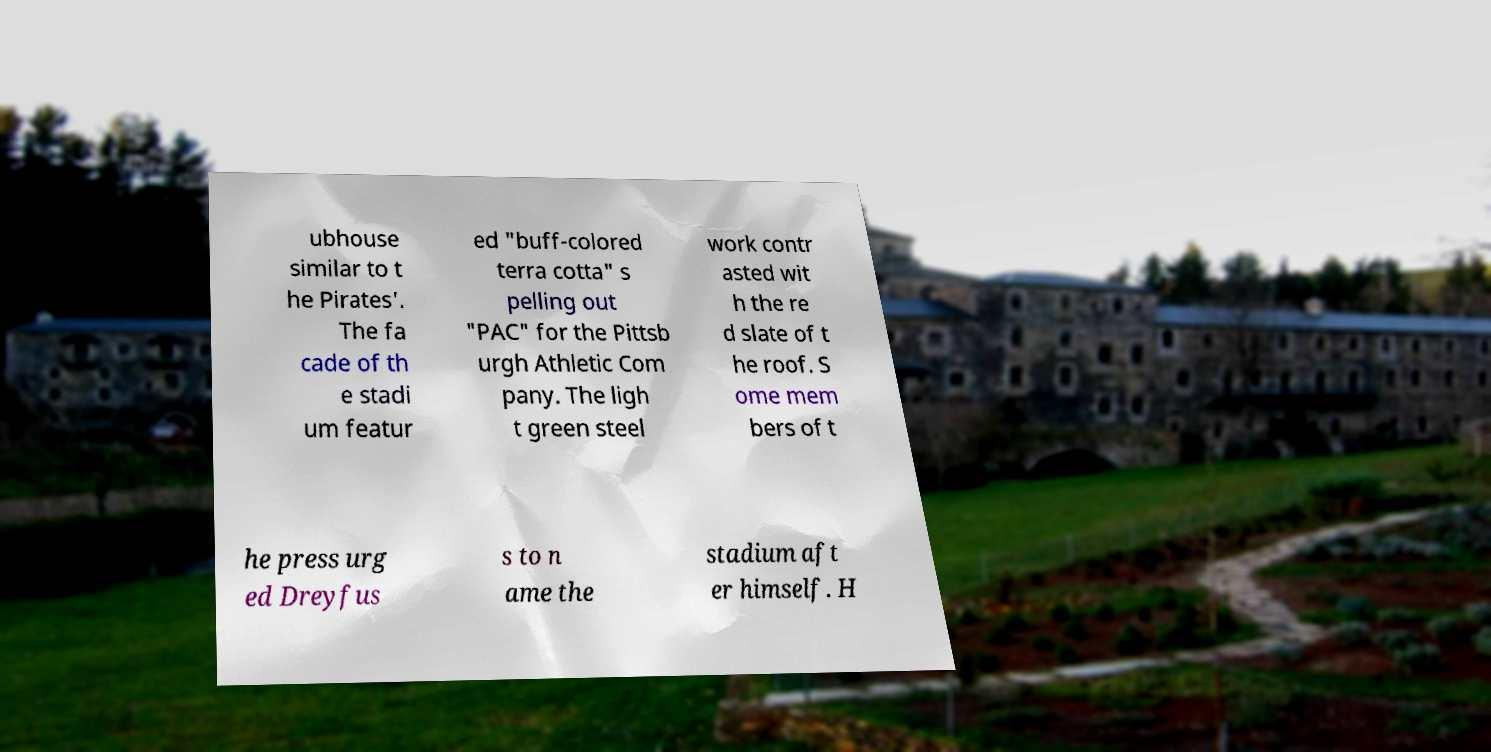Can you read and provide the text displayed in the image?This photo seems to have some interesting text. Can you extract and type it out for me? ubhouse similar to t he Pirates'. The fa cade of th e stadi um featur ed "buff-colored terra cotta" s pelling out "PAC" for the Pittsb urgh Athletic Com pany. The ligh t green steel work contr asted wit h the re d slate of t he roof. S ome mem bers of t he press urg ed Dreyfus s to n ame the stadium aft er himself. H 